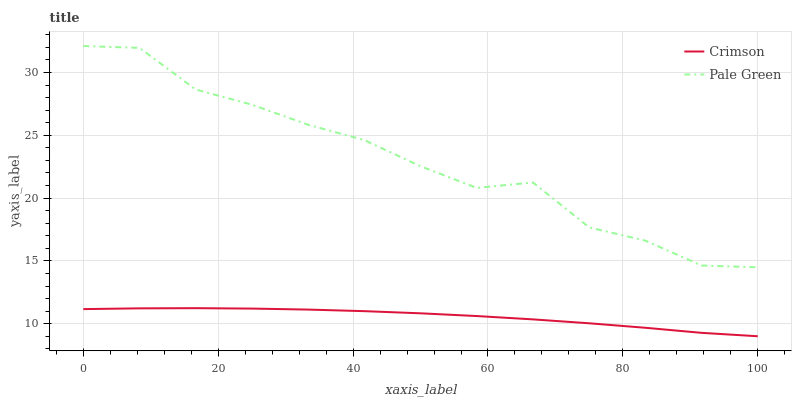Does Pale Green have the minimum area under the curve?
Answer yes or no. No. Is Pale Green the smoothest?
Answer yes or no. No. Does Pale Green have the lowest value?
Answer yes or no. No. Is Crimson less than Pale Green?
Answer yes or no. Yes. Is Pale Green greater than Crimson?
Answer yes or no. Yes. Does Crimson intersect Pale Green?
Answer yes or no. No. 